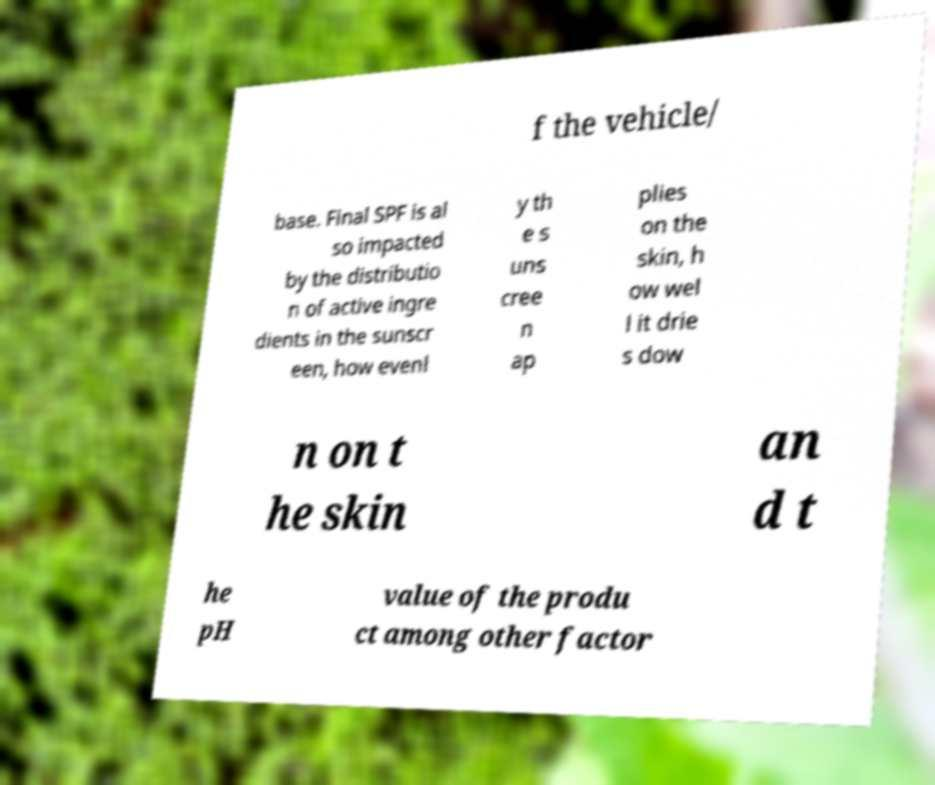I need the written content from this picture converted into text. Can you do that? f the vehicle/ base. Final SPF is al so impacted by the distributio n of active ingre dients in the sunscr een, how evenl y th e s uns cree n ap plies on the skin, h ow wel l it drie s dow n on t he skin an d t he pH value of the produ ct among other factor 